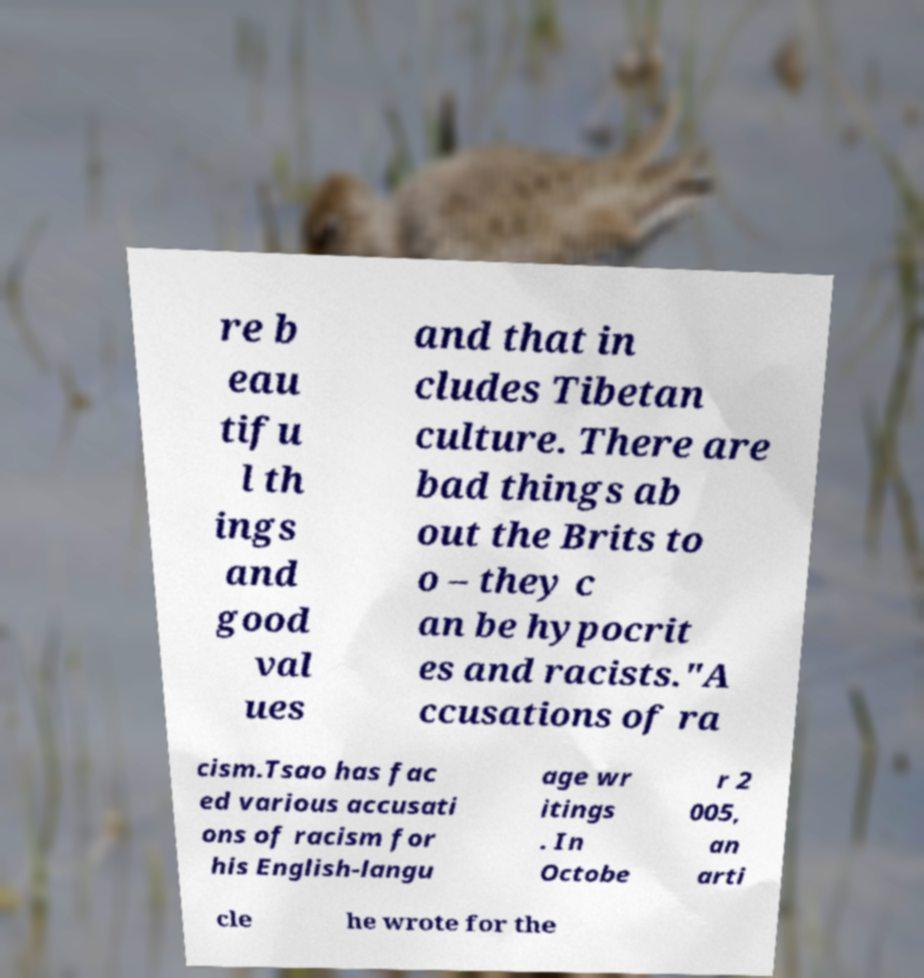I need the written content from this picture converted into text. Can you do that? re b eau tifu l th ings and good val ues and that in cludes Tibetan culture. There are bad things ab out the Brits to o – they c an be hypocrit es and racists."A ccusations of ra cism.Tsao has fac ed various accusati ons of racism for his English-langu age wr itings . In Octobe r 2 005, an arti cle he wrote for the 